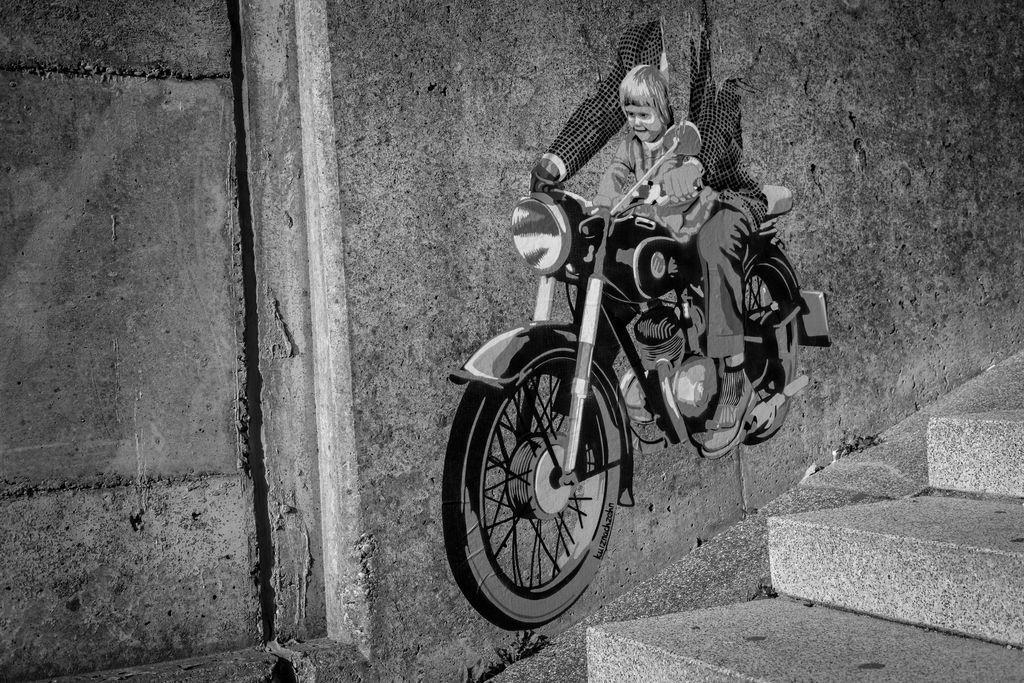Describe this image in one or two sentences. In this image we can see a black and white picture of a painting on the wall in which we can see two people sitting on the motorcycle. To the right side, we can see a staircase. 